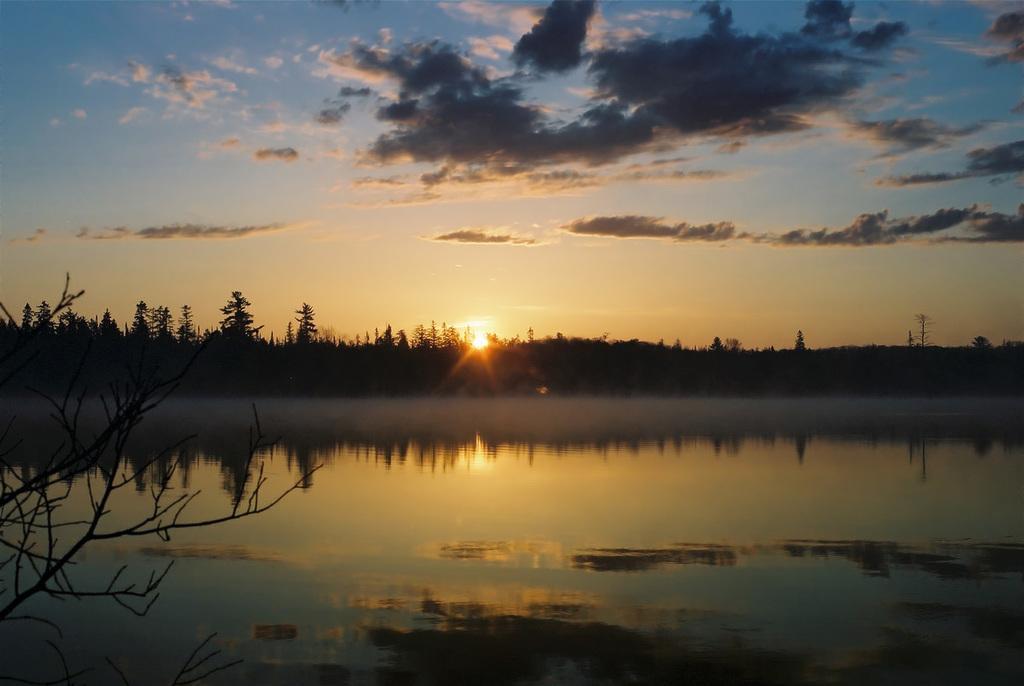Could you give a brief overview of what you see in this image? In this image we can see water and some trees, in the background, we can see sunlight and sky with clouds. 